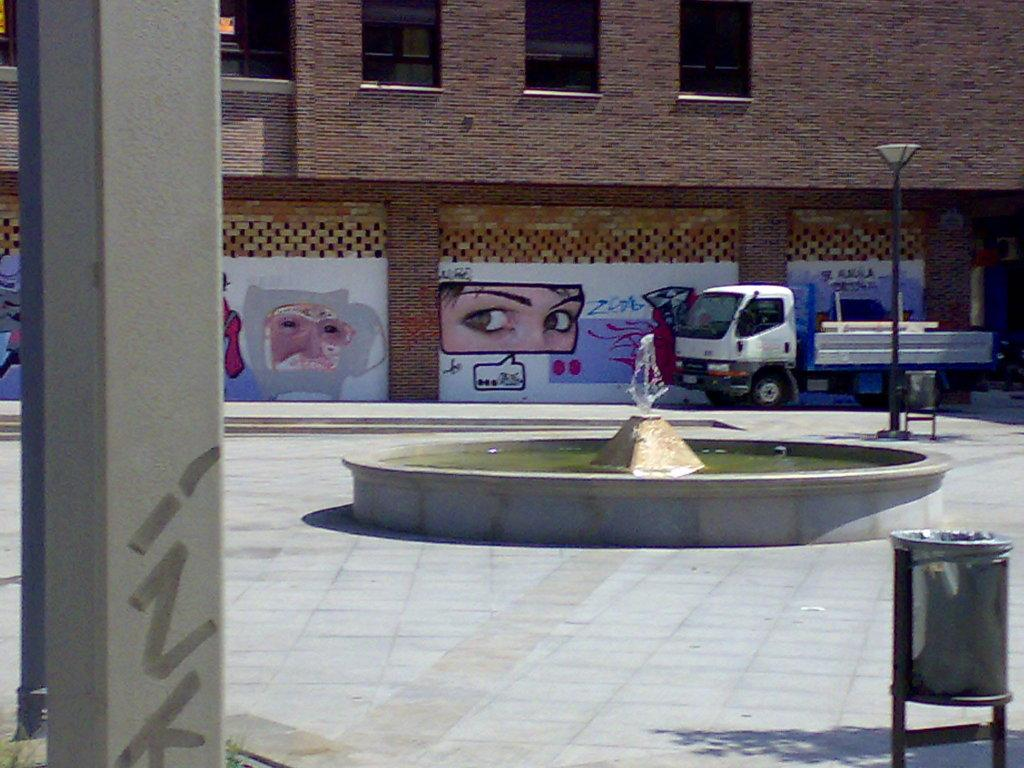What type of structure is visible in the image? There is a building in the image. What can be seen on the wall of the building? There is a painting on the wall of the building. What is a water feature present in the image? There is a fountain in the image. What type of street furniture is present in the image? There is a light pole in the image. What architectural element can be seen in the image? There is a pillar in the image. What is used for waste disposal in the image? There is a dustbin in the image. What type of vehicle is on the ground in the image? There is a vehicle on the ground in the image. Can you see any ants crawling on the vehicle in the image? There are no ants visible in the image. What effect does the hose have on the fountain in the image? There is no hose present in the image, so it cannot have any effect on the fountain. 